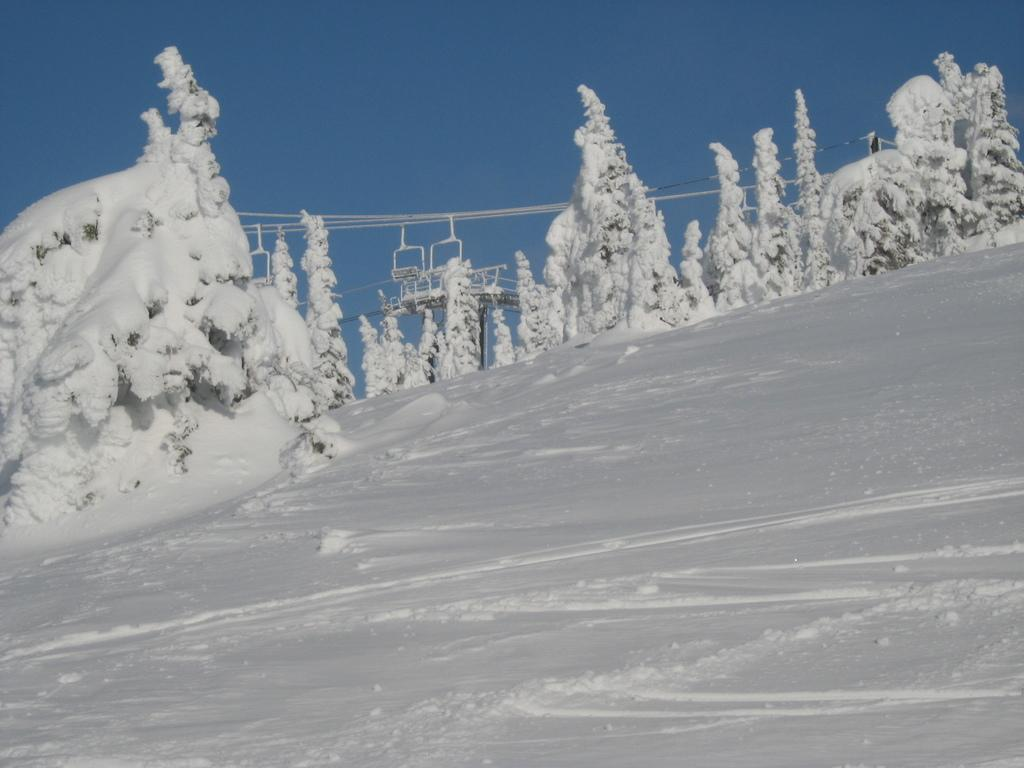What type of vegetation can be seen in the image? There are trees in the image. What is covering the trees in the image? Snow is formed on the trees. What else can be seen in the background of the image? There are wires in the background of the image. What is the condition of the sky in the image? The sky appears clear in the image. What type of linen is draped over the trees in the image? There is no linen present in the image; it is snow that is covering the trees. What advice can be given to the crowd in the image? There is no crowd present in the image, so no advice can be given. 